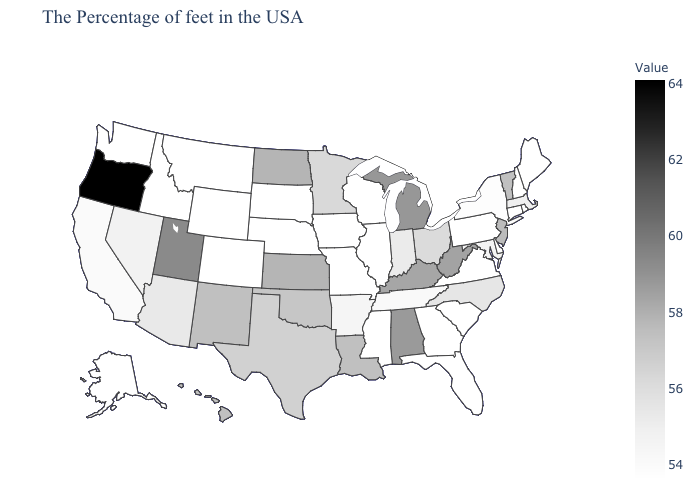Among the states that border South Dakota , does Wyoming have the lowest value?
Short answer required. Yes. Does Missouri have a higher value than Hawaii?
Be succinct. No. Which states have the lowest value in the Northeast?
Quick response, please. Maine, Rhode Island, New Hampshire, Connecticut, Pennsylvania. Among the states that border Utah , which have the highest value?
Be succinct. New Mexico. Does New Hampshire have a lower value than Michigan?
Write a very short answer. Yes. Among the states that border South Carolina , does North Carolina have the lowest value?
Write a very short answer. No. 